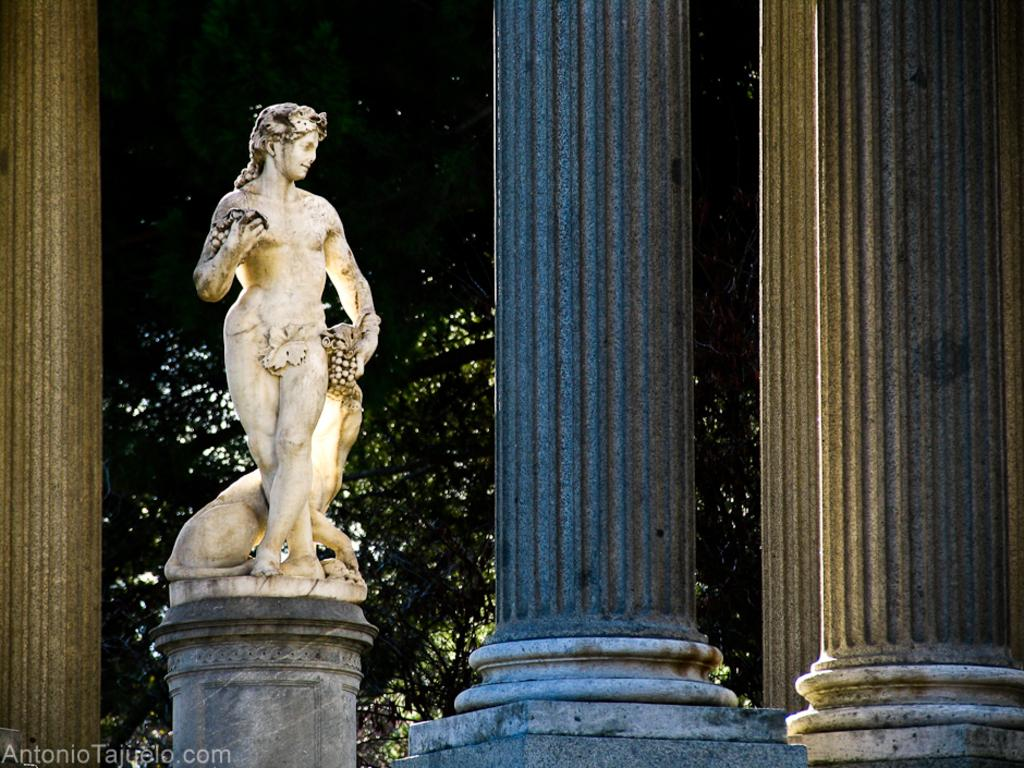What is the main subject of the image? There is a sculpture in the image. What architectural features can be seen in the image? There are pillars in the image. What can be seen in the background of the image? There are trees and the sky visible in the background of the image. What type of cushion is being used to support the beam in the image? There is no cushion or beam present in the image; it features a sculpture and pillars. What type of insurance policy is being advertised in the image? There is no insurance policy or advertisement present in the image. 